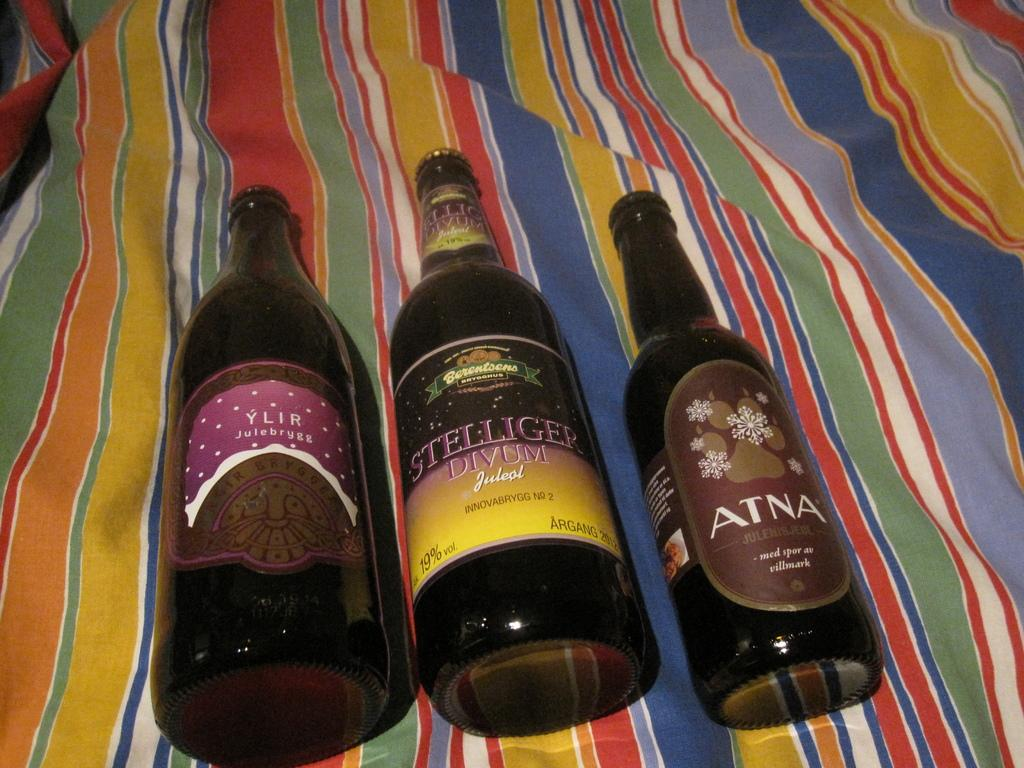<image>
Write a terse but informative summary of the picture. Three large bottles, including Atna, on a rainbow striped sheet. 